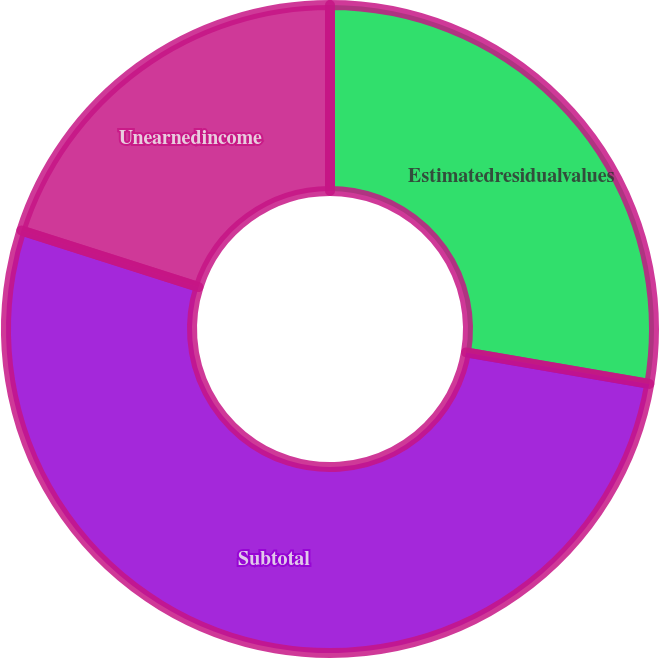Convert chart. <chart><loc_0><loc_0><loc_500><loc_500><pie_chart><fcel>Estimatedresidualvalues<fcel>Subtotal<fcel>Unearnedincome<nl><fcel>27.71%<fcel>52.21%<fcel>20.08%<nl></chart> 